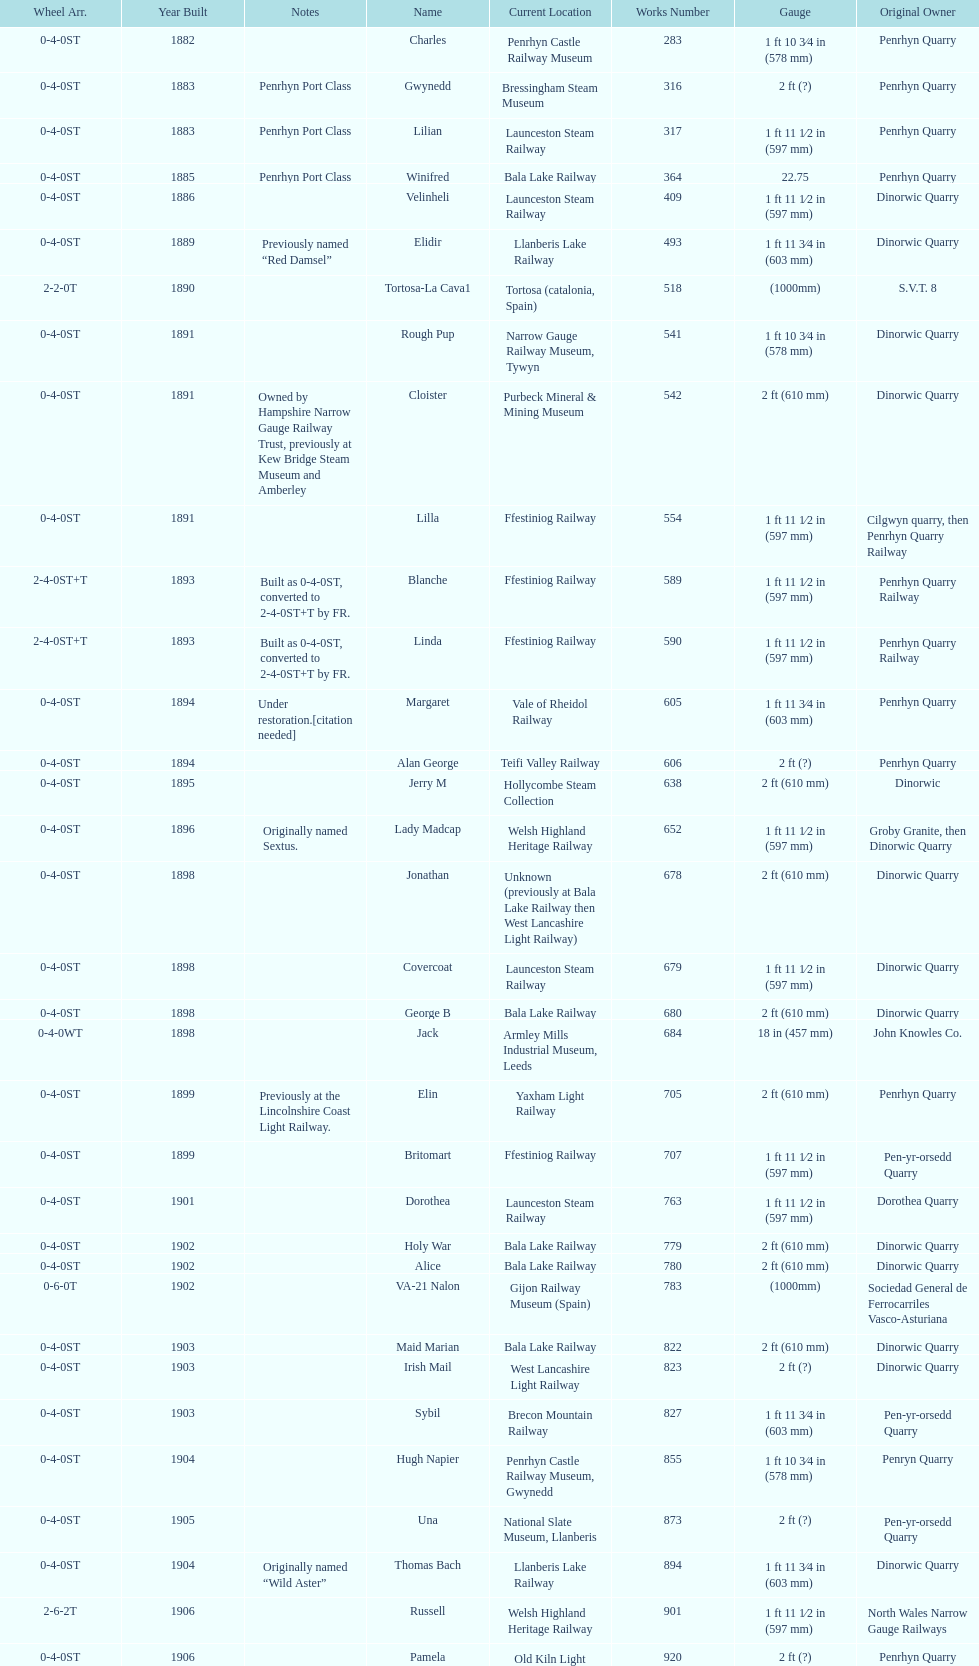How many steam locomotives are currently located at the bala lake railway? 364. 